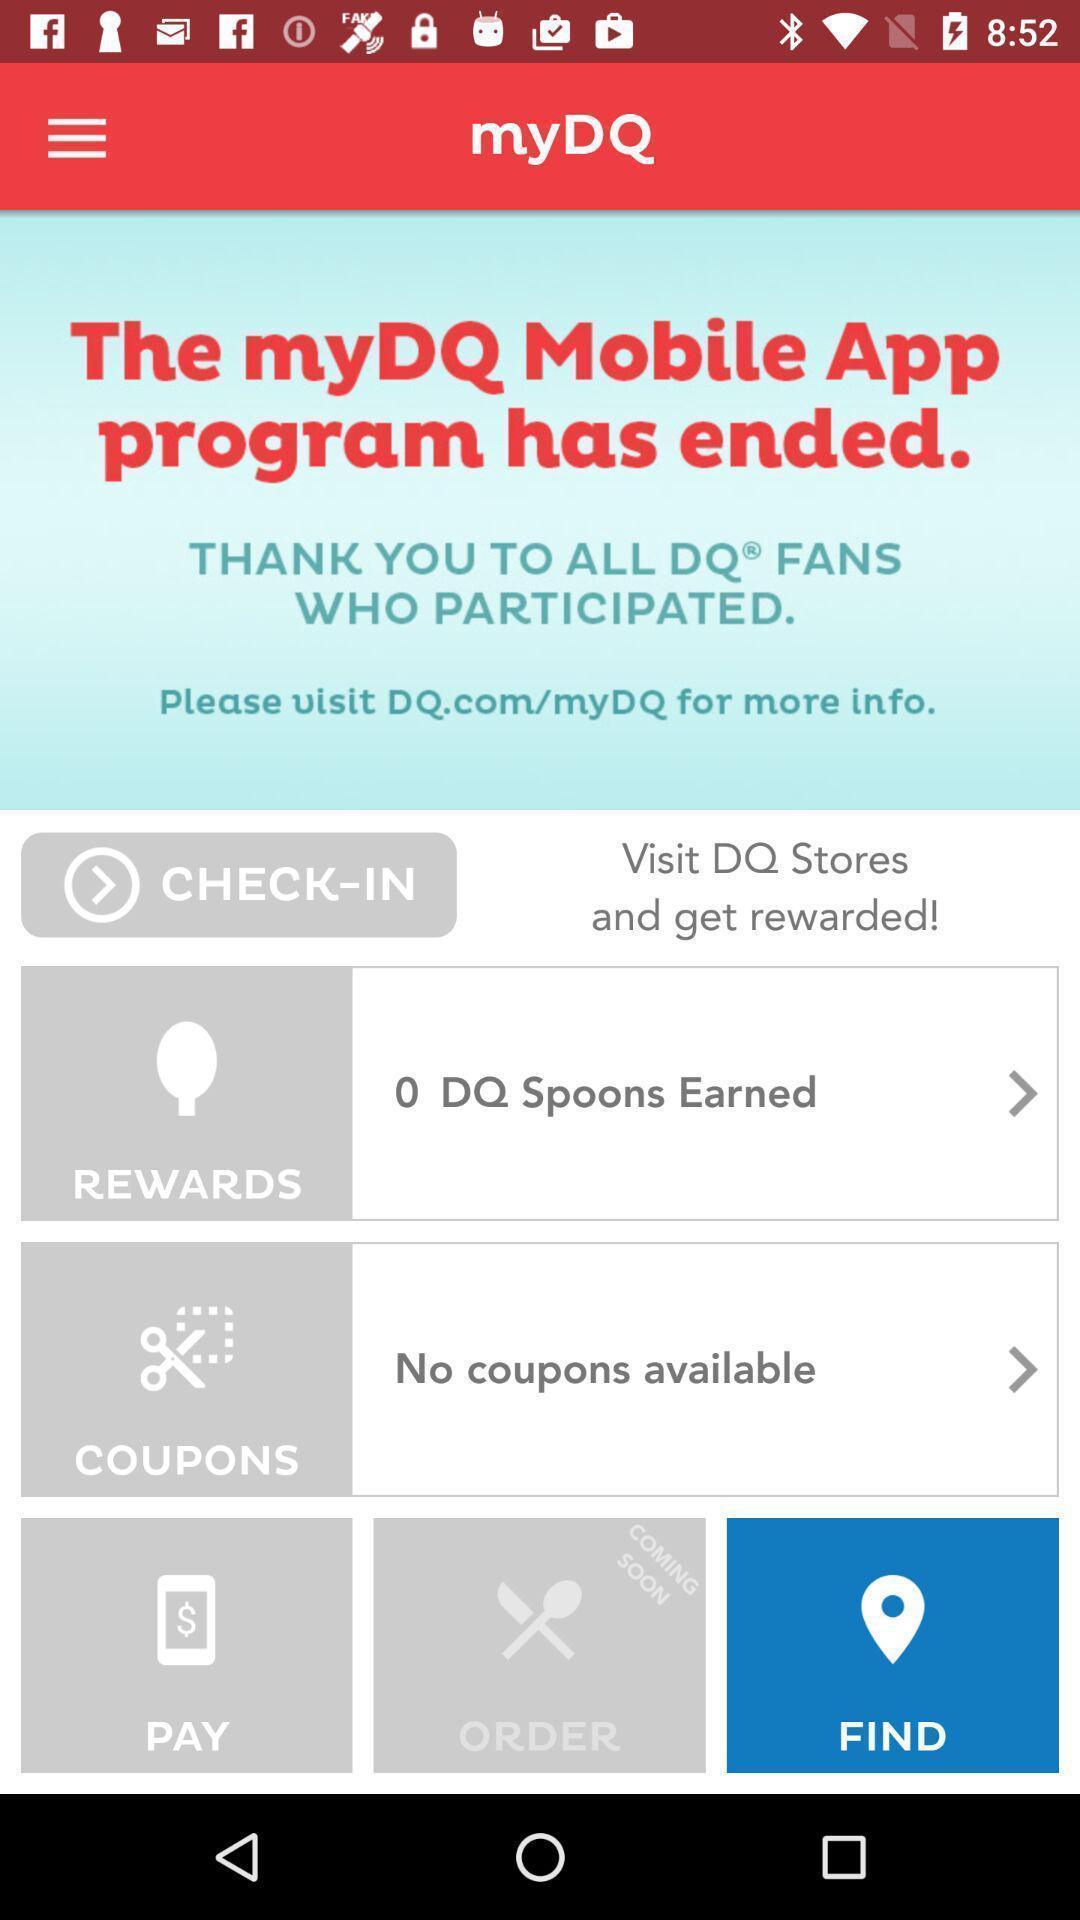Summarize the information in this screenshot. Window displaying a food app. 